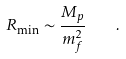<formula> <loc_0><loc_0><loc_500><loc_500>R _ { \min } \sim \frac { M _ { p } } { m _ { f } ^ { 2 } } \quad .</formula> 